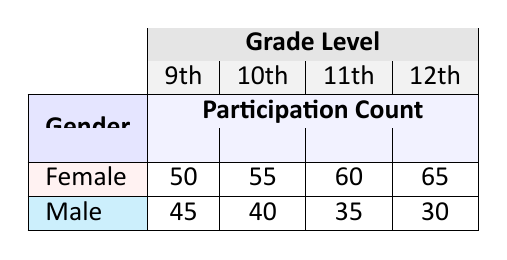What is the participation count for 10th grade females? The table indicates that the participation count for females in 10th grade is listed in the corresponding row under the 10th column. The value is 55.
Answer: 55 Which gender had the highest participation in 12th grade? By comparing the participation counts in the 12th grade row, males have a participation count of 30 while females have a count of 65. The higher value indicates that females had the highest participation.
Answer: Female What is the total participation count for male students across all grades? To find the total for male students, sum the participation counts from each grade level: 45 (9th) + 40 (10th) + 35 (11th) + 30 (12th) = 150.
Answer: 150 Is it true that female students had higher participation than male students in 11th grade? In the table, the participation count for 11th grade females is 60 and for males is 35. Since 60 is greater than 35, the statement is true.
Answer: Yes What is the average participation count for all grades combined for female students? The total participation for female students is calculated by adding 50 (9th) + 55 (10th) + 60 (11th) + 65 (12th) = 230. There are four data points (grades), so the average is 230/4 = 57.5.
Answer: 57.5 Which grade showed the largest difference in participation count between male and female students? For each grade, subtract the male participation count from the female count. The differences are as follows: 9th (50-45=5), 10th (55-40=15), 11th (60-35=25), 12th (65-30=35). The largest difference is 35 in 12th grade.
Answer: 12th grade What gender had the lowest participation in 9th grade? Looking at the 9th grade row, males have a participation count of 45 while females have 50. Therefore, males had the lowest participation in this grade.
Answer: Male What is the total female participation across 9th and 10th grades? To find the total for females in the 9th and 10th grades, sum their participation counts: 50 (9th) + 55 (10th) = 105.
Answer: 105 What is the difference in participation counts between the highest and lowest participating gender in 10th grade? The highest participation in 10th grade is for females (55), and the lowest is for males (40). The difference is 55 - 40 = 15.
Answer: 15 